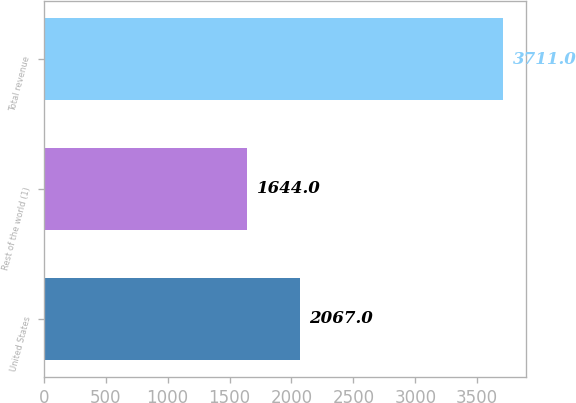Convert chart. <chart><loc_0><loc_0><loc_500><loc_500><bar_chart><fcel>United States<fcel>Rest of the world (1)<fcel>Total revenue<nl><fcel>2067<fcel>1644<fcel>3711<nl></chart> 